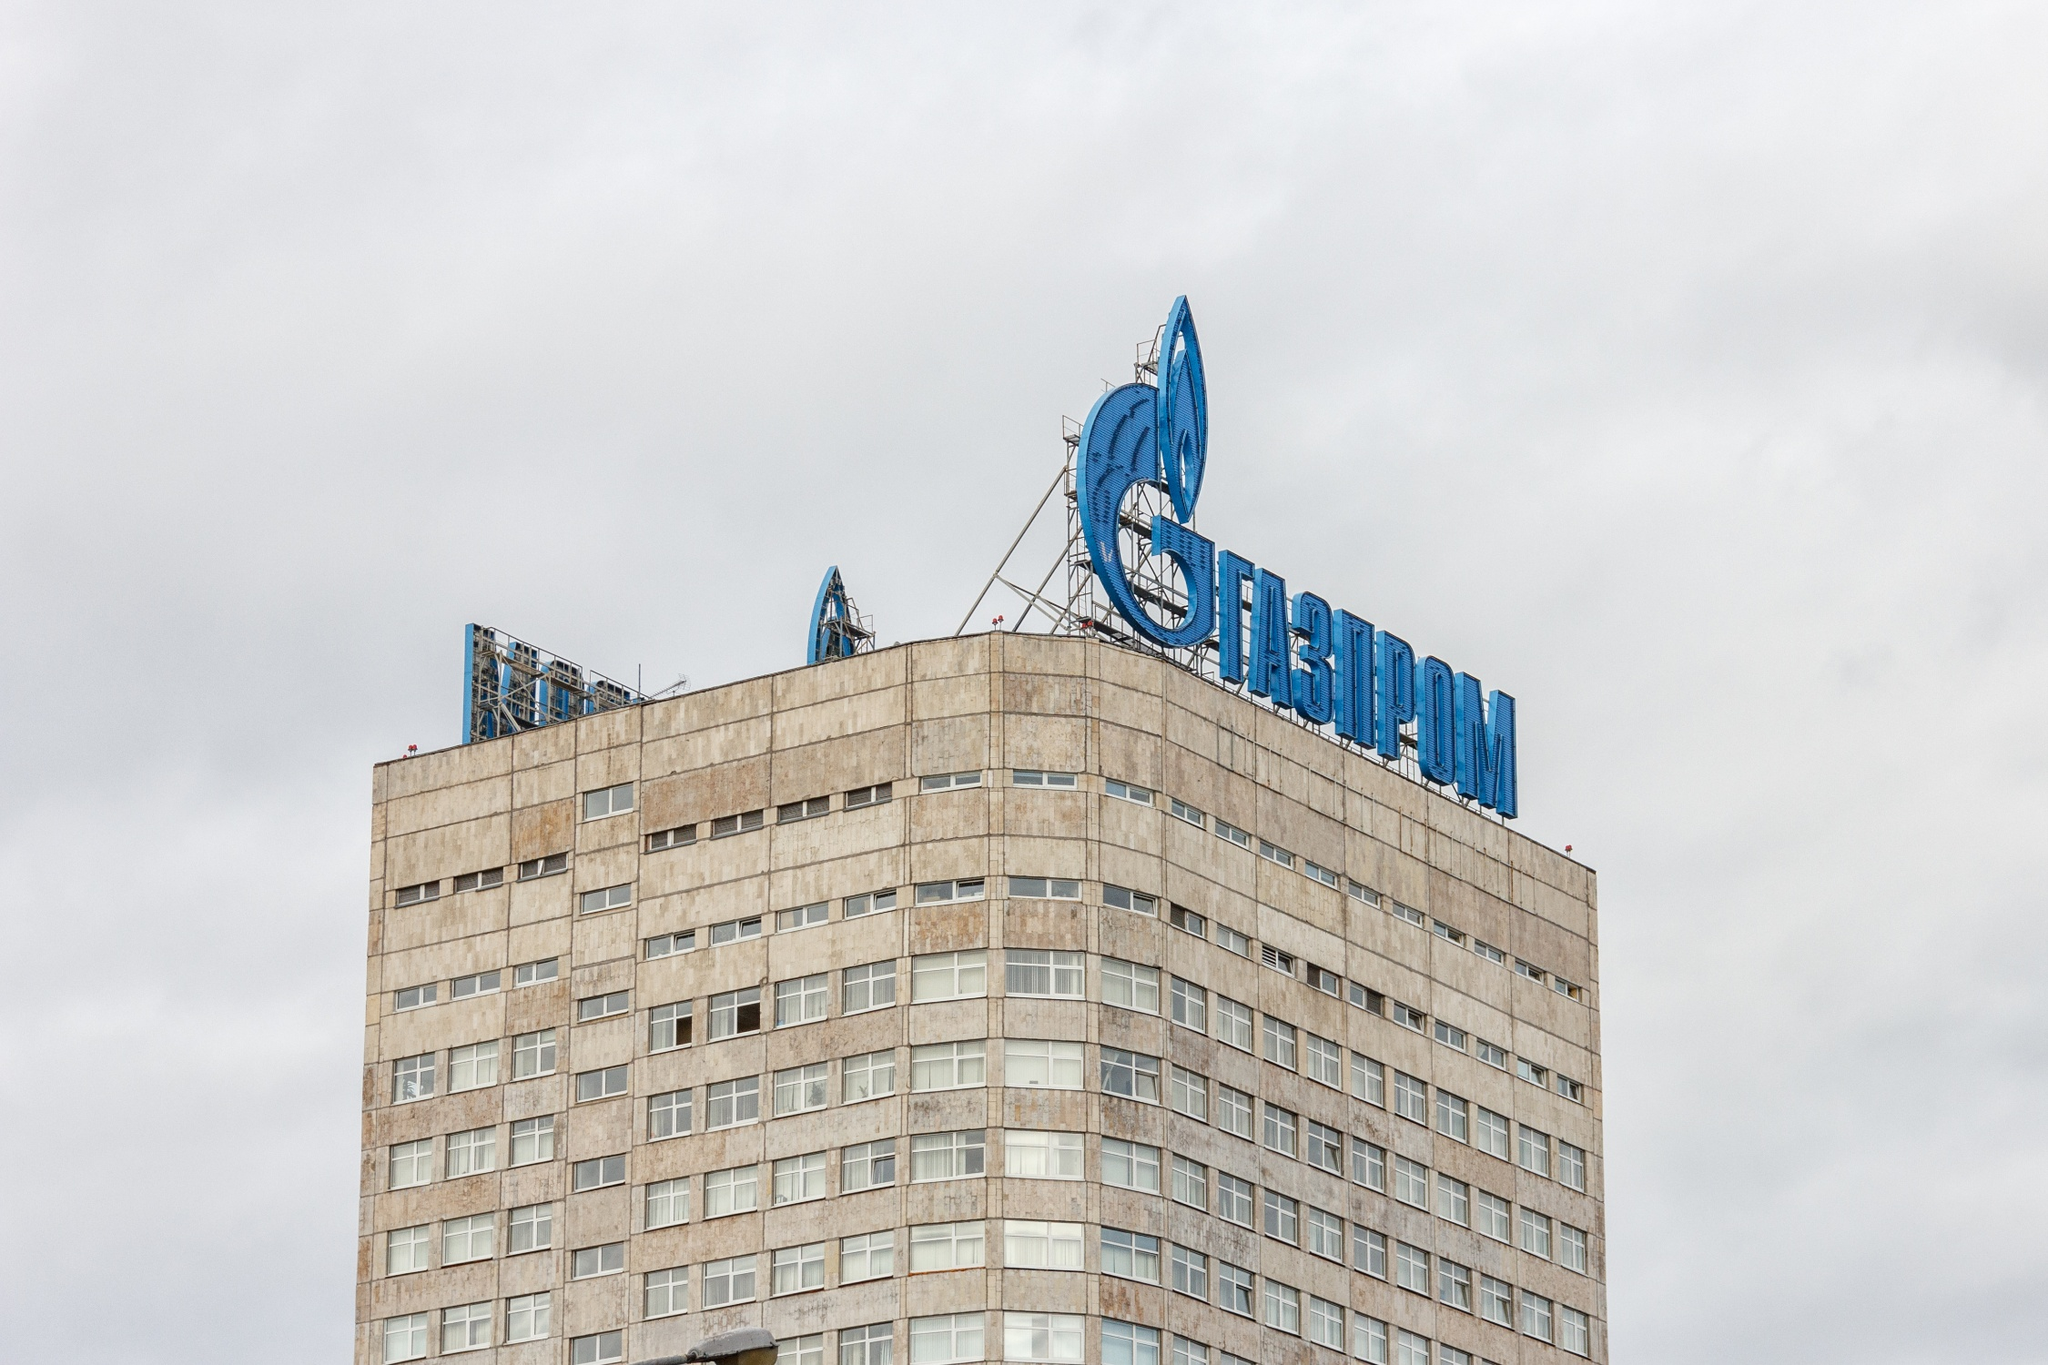Can you describe the main features of this image for me? The image depicts the Gazprom headquarters in Moscow, Russia. This building is notable for its modern architectural design, characterized by its towering rectangular structure with a unique curved top. The façade is dominated by neutral tones, contrasted by the prominent Gazprom logo at the top, which features a blue flame. Overhead, the sky is cloudy and gray, emphasizing the building's height and presence in the urban landscape. The perspective of the photo accentuates the building's scale, making it a significant feature of Moscow's skyline. 